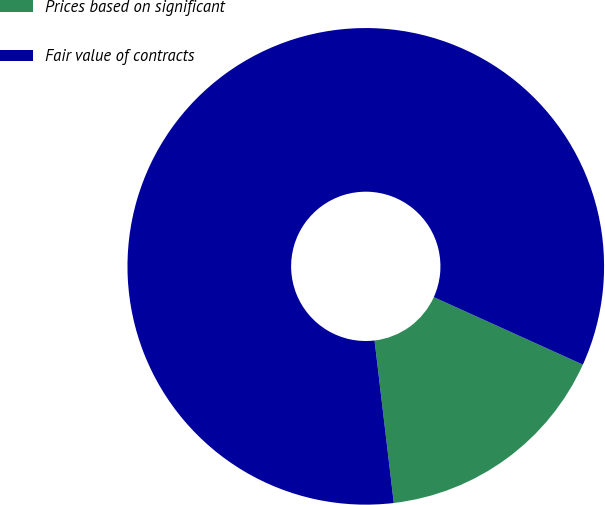<chart> <loc_0><loc_0><loc_500><loc_500><pie_chart><fcel>Prices based on significant<fcel>Fair value of contracts<nl><fcel>16.36%<fcel>83.64%<nl></chart> 